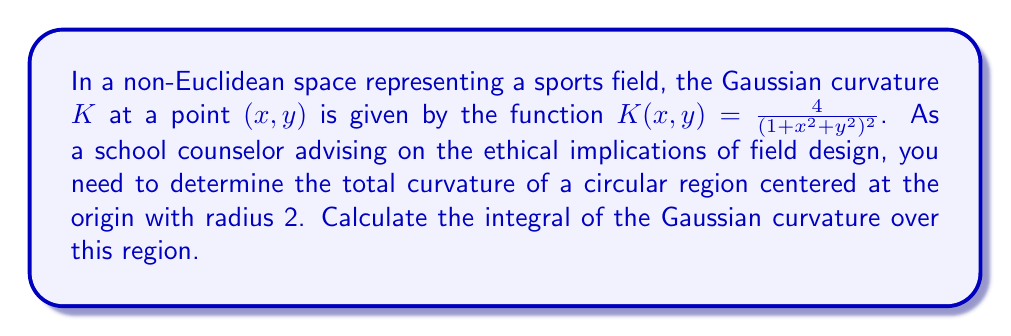Show me your answer to this math problem. To solve this problem, we'll follow these steps:

1) The total curvature is given by the surface integral of the Gaussian curvature over the region:

   $$\iint_R K(x,y) dA$$

2) Given the circular region centered at the origin with radius 2, we can use polar coordinates:
   $x = r\cos\theta$, $y = r\sin\theta$, $0 \leq r \leq 2$, $0 \leq \theta \leq 2\pi$

3) The Jacobian for the transformation to polar coordinates is $r$, so $dA = r dr d\theta$

4) Substituting into the Gaussian curvature function:

   $$K(r,\theta) = \frac{4}{(1 + r^2)^2}$$

5) Our integral becomes:

   $$\int_0^{2\pi} \int_0^2 \frac{4}{(1 + r^2)^2} r dr d\theta$$

6) The inner integral doesn't depend on $\theta$, so we can separate:

   $$2\pi \int_0^2 \frac{4r}{(1 + r^2)^2} dr$$

7) To solve this, let $u = 1 + r^2$, then $du = 2r dr$, or $r dr = \frac{1}{2}du$:

   $$2\pi \int_1^5 \frac{2}{u^2} du$$

8) Integrate:

   $$2\pi \left[-\frac{2}{u}\right]_1^5 = 2\pi \left(-\frac{2}{5} + 2\right) = 2\pi \cdot \frac{8}{5} = \frac{16\pi}{5}$$

This result represents the total curvature of the circular region.
Answer: $\frac{16\pi}{5}$ 